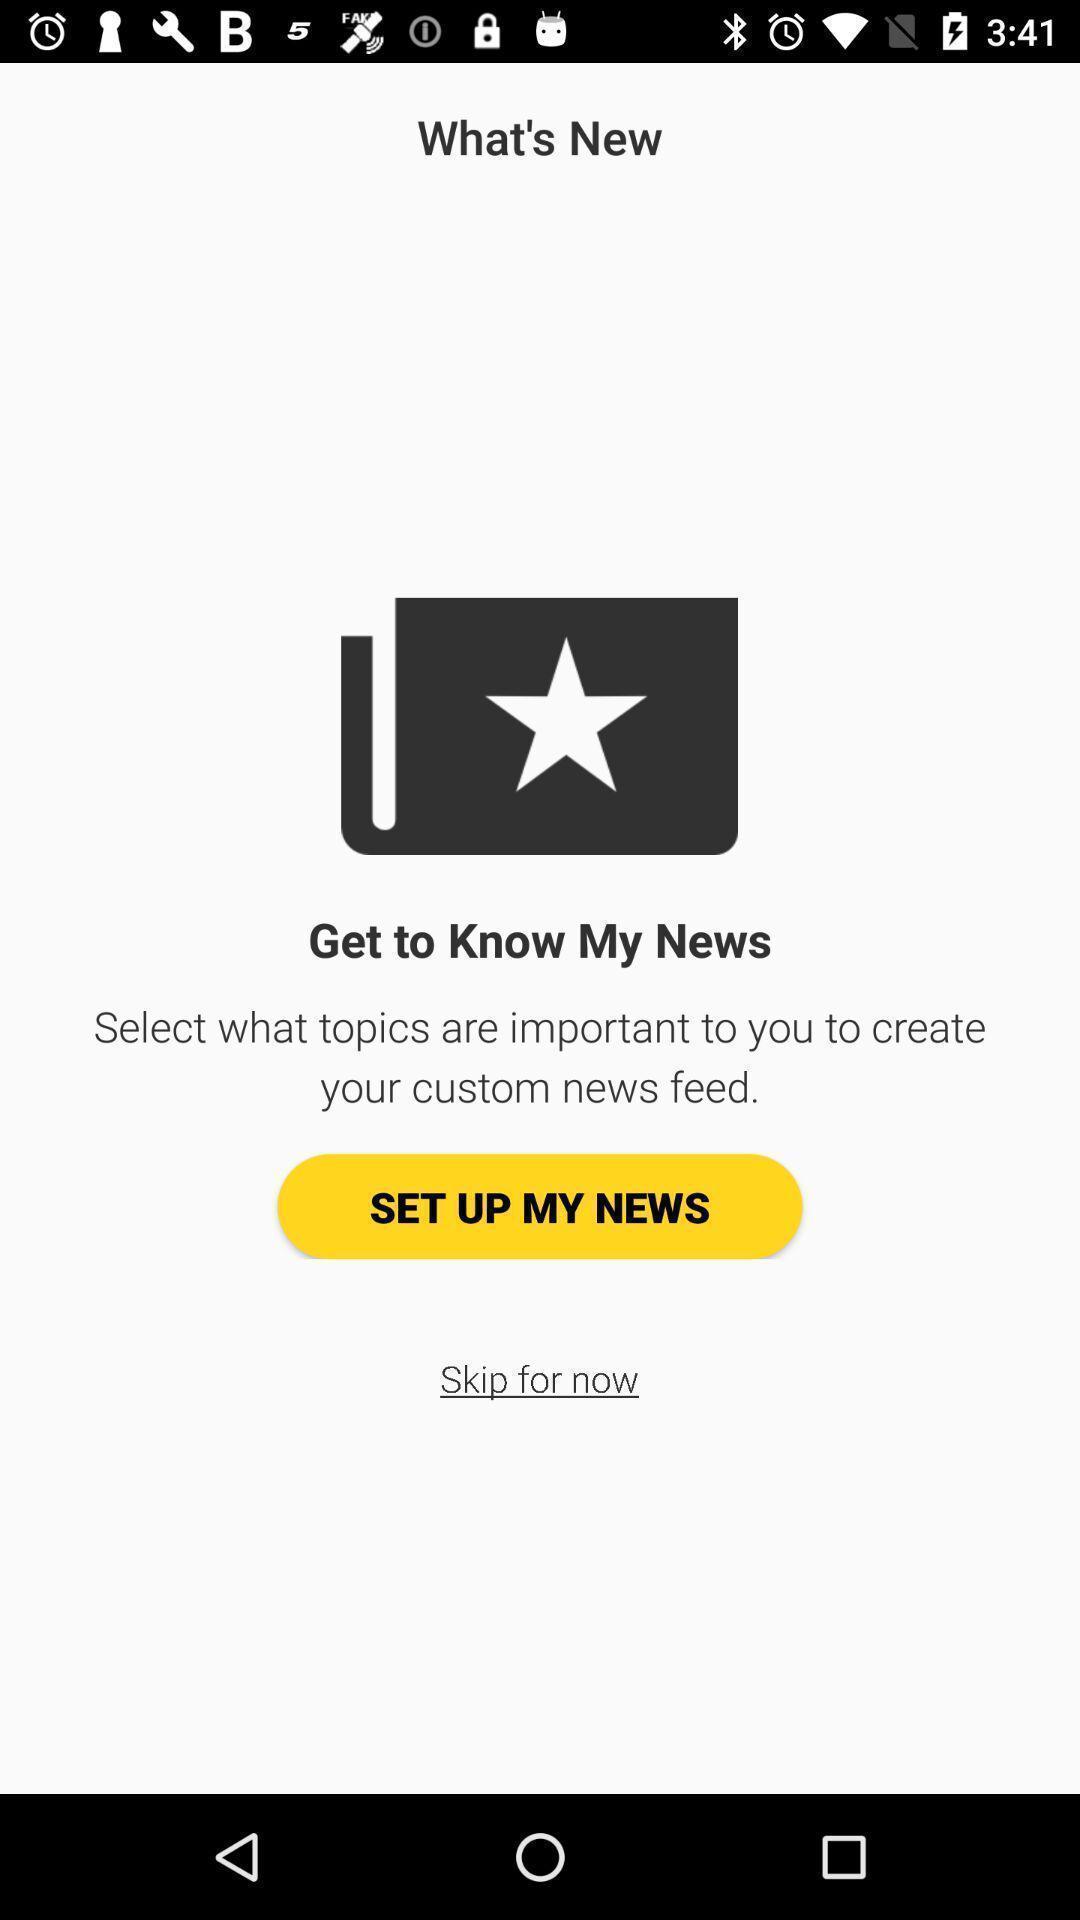Describe the key features of this screenshot. Page shows to set up button. 